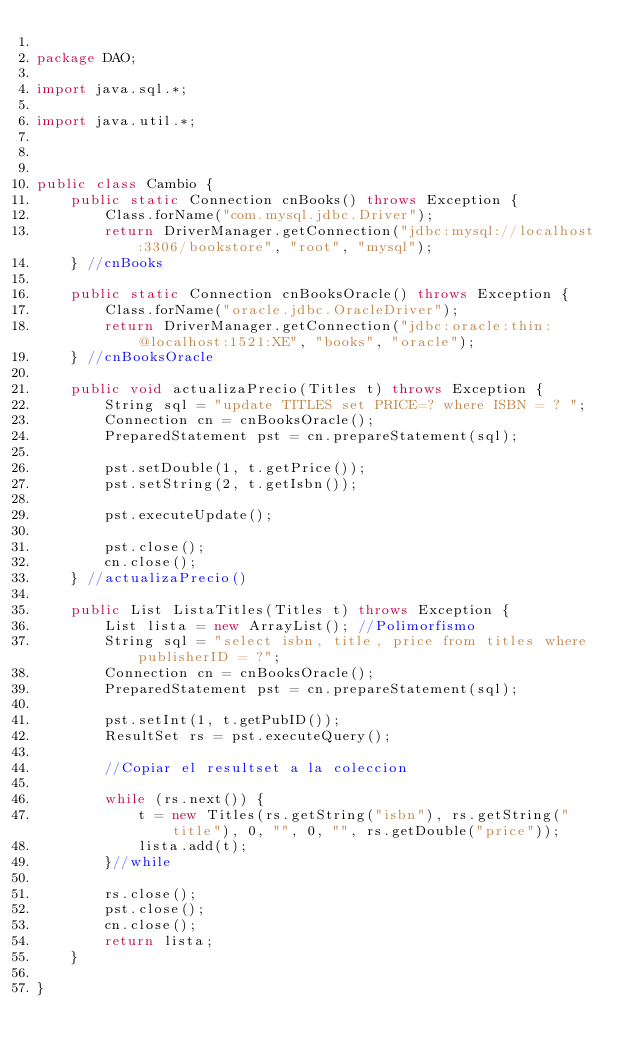<code> <loc_0><loc_0><loc_500><loc_500><_Java_>
package DAO;

import java.sql.*;

import java.util.*;



public class Cambio {
    public static Connection cnBooks() throws Exception {
        Class.forName("com.mysql.jdbc.Driver");
        return DriverManager.getConnection("jdbc:mysql://localhost:3306/bookstore", "root", "mysql");
    } //cnBooks

    public static Connection cnBooksOracle() throws Exception {
        Class.forName("oracle.jdbc.OracleDriver");
        return DriverManager.getConnection("jdbc:oracle:thin:@localhost:1521:XE", "books", "oracle");
    } //cnBooksOracle

    public void actualizaPrecio(Titles t) throws Exception {
        String sql = "update TITLES set PRICE=? where ISBN = ? ";
        Connection cn = cnBooksOracle();
        PreparedStatement pst = cn.prepareStatement(sql);

        pst.setDouble(1, t.getPrice());
        pst.setString(2, t.getIsbn());

        pst.executeUpdate();

        pst.close();
        cn.close();
    } //actualizaPrecio()

    public List ListaTitles(Titles t) throws Exception {
        List lista = new ArrayList(); //Polimorfismo
        String sql = "select isbn, title, price from titles where publisherID = ?";
        Connection cn = cnBooksOracle();
        PreparedStatement pst = cn.prepareStatement(sql);
        
        pst.setInt(1, t.getPubID());
        ResultSet rs = pst.executeQuery();

        //Copiar el resultset a la coleccion
        
        while (rs.next()) {
            t = new Titles(rs.getString("isbn"), rs.getString("title"), 0, "", 0, "", rs.getDouble("price"));
            lista.add(t);
        }//while

        rs.close();
        pst.close();
        cn.close();
        return lista;
    }
    
}
</code> 